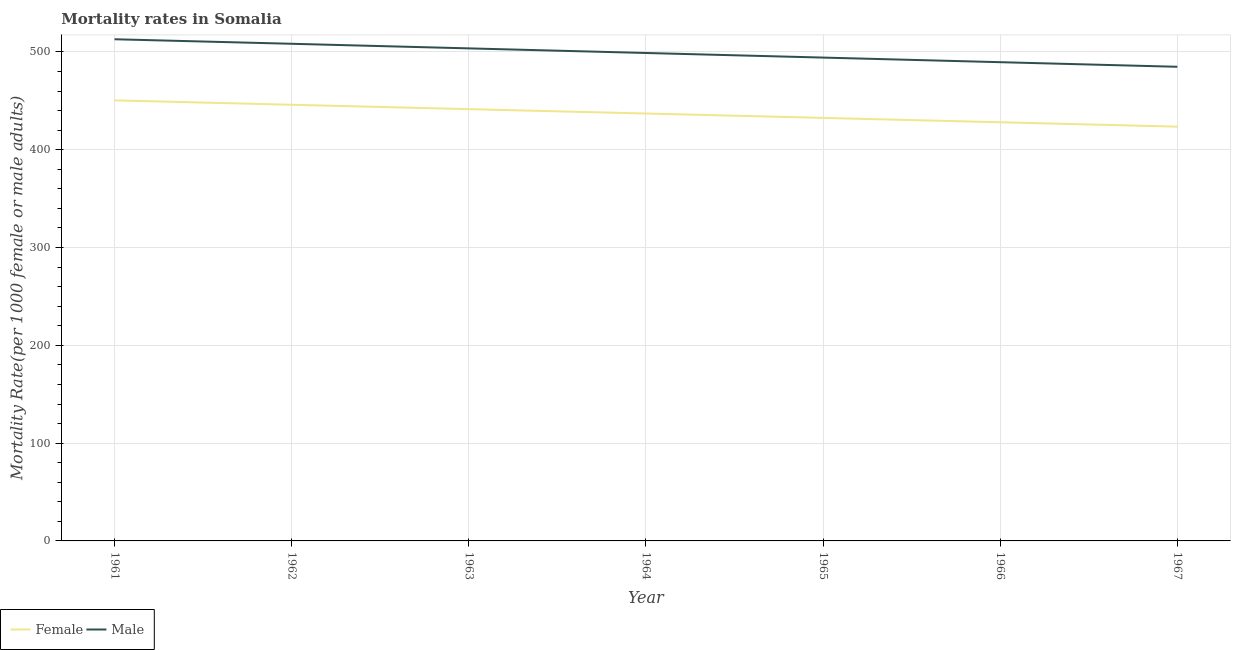Does the line corresponding to female mortality rate intersect with the line corresponding to male mortality rate?
Keep it short and to the point. No. Is the number of lines equal to the number of legend labels?
Your answer should be compact. Yes. What is the female mortality rate in 1961?
Keep it short and to the point. 450.5. Across all years, what is the maximum female mortality rate?
Provide a succinct answer. 450.5. Across all years, what is the minimum female mortality rate?
Give a very brief answer. 423.62. In which year was the male mortality rate maximum?
Your answer should be compact. 1961. In which year was the male mortality rate minimum?
Offer a very short reply. 1967. What is the total female mortality rate in the graph?
Offer a very short reply. 3059.34. What is the difference between the female mortality rate in 1961 and that in 1963?
Ensure brevity in your answer.  8.98. What is the difference between the female mortality rate in 1967 and the male mortality rate in 1962?
Offer a very short reply. -84.73. What is the average male mortality rate per year?
Provide a succinct answer. 498.93. In the year 1963, what is the difference between the female mortality rate and male mortality rate?
Offer a terse response. -62.13. In how many years, is the male mortality rate greater than 160?
Offer a very short reply. 7. What is the ratio of the female mortality rate in 1961 to that in 1965?
Offer a very short reply. 1.04. Is the difference between the female mortality rate in 1964 and 1966 greater than the difference between the male mortality rate in 1964 and 1966?
Make the answer very short. No. What is the difference between the highest and the second highest male mortality rate?
Provide a succinct answer. 4.64. What is the difference between the highest and the lowest female mortality rate?
Your answer should be very brief. 26.88. Does the female mortality rate monotonically increase over the years?
Offer a very short reply. No. Is the male mortality rate strictly greater than the female mortality rate over the years?
Offer a terse response. Yes. Is the female mortality rate strictly less than the male mortality rate over the years?
Ensure brevity in your answer.  Yes. What is the difference between two consecutive major ticks on the Y-axis?
Your response must be concise. 100. Where does the legend appear in the graph?
Your answer should be very brief. Bottom left. How many legend labels are there?
Ensure brevity in your answer.  2. What is the title of the graph?
Make the answer very short. Mortality rates in Somalia. What is the label or title of the X-axis?
Your answer should be very brief. Year. What is the label or title of the Y-axis?
Your answer should be compact. Mortality Rate(per 1000 female or male adults). What is the Mortality Rate(per 1000 female or male adults) in Female in 1961?
Your response must be concise. 450.5. What is the Mortality Rate(per 1000 female or male adults) in Male in 1961?
Provide a short and direct response. 512.99. What is the Mortality Rate(per 1000 female or male adults) of Female in 1962?
Make the answer very short. 446. What is the Mortality Rate(per 1000 female or male adults) in Male in 1962?
Offer a very short reply. 508.35. What is the Mortality Rate(per 1000 female or male adults) of Female in 1963?
Ensure brevity in your answer.  441.52. What is the Mortality Rate(per 1000 female or male adults) in Male in 1963?
Offer a terse response. 503.65. What is the Mortality Rate(per 1000 female or male adults) of Female in 1964?
Your answer should be very brief. 437.04. What is the Mortality Rate(per 1000 female or male adults) in Male in 1964?
Your answer should be very brief. 498.94. What is the Mortality Rate(per 1000 female or male adults) of Female in 1965?
Keep it short and to the point. 432.57. What is the Mortality Rate(per 1000 female or male adults) of Male in 1965?
Your answer should be very brief. 494.24. What is the Mortality Rate(per 1000 female or male adults) of Female in 1966?
Provide a short and direct response. 428.09. What is the Mortality Rate(per 1000 female or male adults) of Male in 1966?
Your answer should be very brief. 489.53. What is the Mortality Rate(per 1000 female or male adults) in Female in 1967?
Offer a very short reply. 423.62. What is the Mortality Rate(per 1000 female or male adults) of Male in 1967?
Make the answer very short. 484.82. Across all years, what is the maximum Mortality Rate(per 1000 female or male adults) of Female?
Your response must be concise. 450.5. Across all years, what is the maximum Mortality Rate(per 1000 female or male adults) in Male?
Give a very brief answer. 512.99. Across all years, what is the minimum Mortality Rate(per 1000 female or male adults) of Female?
Provide a short and direct response. 423.62. Across all years, what is the minimum Mortality Rate(per 1000 female or male adults) of Male?
Offer a terse response. 484.82. What is the total Mortality Rate(per 1000 female or male adults) of Female in the graph?
Offer a very short reply. 3059.34. What is the total Mortality Rate(per 1000 female or male adults) of Male in the graph?
Give a very brief answer. 3492.51. What is the difference between the Mortality Rate(per 1000 female or male adults) of Female in 1961 and that in 1962?
Your response must be concise. 4.5. What is the difference between the Mortality Rate(per 1000 female or male adults) in Male in 1961 and that in 1962?
Ensure brevity in your answer.  4.64. What is the difference between the Mortality Rate(per 1000 female or male adults) in Female in 1961 and that in 1963?
Offer a very short reply. 8.98. What is the difference between the Mortality Rate(per 1000 female or male adults) in Male in 1961 and that in 1963?
Give a very brief answer. 9.34. What is the difference between the Mortality Rate(per 1000 female or male adults) in Female in 1961 and that in 1964?
Make the answer very short. 13.45. What is the difference between the Mortality Rate(per 1000 female or male adults) in Male in 1961 and that in 1964?
Your answer should be compact. 14.05. What is the difference between the Mortality Rate(per 1000 female or male adults) in Female in 1961 and that in 1965?
Offer a very short reply. 17.93. What is the difference between the Mortality Rate(per 1000 female or male adults) in Male in 1961 and that in 1965?
Make the answer very short. 18.75. What is the difference between the Mortality Rate(per 1000 female or male adults) in Female in 1961 and that in 1966?
Provide a short and direct response. 22.4. What is the difference between the Mortality Rate(per 1000 female or male adults) in Male in 1961 and that in 1966?
Give a very brief answer. 23.46. What is the difference between the Mortality Rate(per 1000 female or male adults) of Female in 1961 and that in 1967?
Make the answer very short. 26.88. What is the difference between the Mortality Rate(per 1000 female or male adults) of Male in 1961 and that in 1967?
Provide a short and direct response. 28.16. What is the difference between the Mortality Rate(per 1000 female or male adults) in Female in 1962 and that in 1963?
Offer a very short reply. 4.48. What is the difference between the Mortality Rate(per 1000 female or male adults) of Male in 1962 and that in 1963?
Ensure brevity in your answer.  4.71. What is the difference between the Mortality Rate(per 1000 female or male adults) of Female in 1962 and that in 1964?
Give a very brief answer. 8.95. What is the difference between the Mortality Rate(per 1000 female or male adults) in Male in 1962 and that in 1964?
Keep it short and to the point. 9.41. What is the difference between the Mortality Rate(per 1000 female or male adults) in Female in 1962 and that in 1965?
Offer a terse response. 13.43. What is the difference between the Mortality Rate(per 1000 female or male adults) of Male in 1962 and that in 1965?
Provide a succinct answer. 14.12. What is the difference between the Mortality Rate(per 1000 female or male adults) in Female in 1962 and that in 1966?
Offer a terse response. 17.9. What is the difference between the Mortality Rate(per 1000 female or male adults) of Male in 1962 and that in 1966?
Give a very brief answer. 18.82. What is the difference between the Mortality Rate(per 1000 female or male adults) in Female in 1962 and that in 1967?
Your answer should be compact. 22.38. What is the difference between the Mortality Rate(per 1000 female or male adults) in Male in 1962 and that in 1967?
Ensure brevity in your answer.  23.53. What is the difference between the Mortality Rate(per 1000 female or male adults) of Female in 1963 and that in 1964?
Ensure brevity in your answer.  4.47. What is the difference between the Mortality Rate(per 1000 female or male adults) in Male in 1963 and that in 1964?
Provide a short and direct response. 4.71. What is the difference between the Mortality Rate(per 1000 female or male adults) of Female in 1963 and that in 1965?
Make the answer very short. 8.95. What is the difference between the Mortality Rate(per 1000 female or male adults) in Male in 1963 and that in 1965?
Offer a terse response. 9.41. What is the difference between the Mortality Rate(per 1000 female or male adults) in Female in 1963 and that in 1966?
Offer a very short reply. 13.43. What is the difference between the Mortality Rate(per 1000 female or male adults) in Male in 1963 and that in 1966?
Offer a terse response. 14.12. What is the difference between the Mortality Rate(per 1000 female or male adults) of Female in 1963 and that in 1967?
Provide a short and direct response. 17.9. What is the difference between the Mortality Rate(per 1000 female or male adults) in Male in 1963 and that in 1967?
Offer a very short reply. 18.82. What is the difference between the Mortality Rate(per 1000 female or male adults) of Female in 1964 and that in 1965?
Offer a very short reply. 4.47. What is the difference between the Mortality Rate(per 1000 female or male adults) in Male in 1964 and that in 1965?
Provide a short and direct response. 4.71. What is the difference between the Mortality Rate(per 1000 female or male adults) of Female in 1964 and that in 1966?
Your answer should be very brief. 8.95. What is the difference between the Mortality Rate(per 1000 female or male adults) in Male in 1964 and that in 1966?
Your answer should be very brief. 9.41. What is the difference between the Mortality Rate(per 1000 female or male adults) in Female in 1964 and that in 1967?
Ensure brevity in your answer.  13.43. What is the difference between the Mortality Rate(per 1000 female or male adults) in Male in 1964 and that in 1967?
Your response must be concise. 14.12. What is the difference between the Mortality Rate(per 1000 female or male adults) in Female in 1965 and that in 1966?
Your answer should be very brief. 4.47. What is the difference between the Mortality Rate(per 1000 female or male adults) in Male in 1965 and that in 1966?
Provide a succinct answer. 4.71. What is the difference between the Mortality Rate(per 1000 female or male adults) in Female in 1965 and that in 1967?
Give a very brief answer. 8.95. What is the difference between the Mortality Rate(per 1000 female or male adults) of Male in 1965 and that in 1967?
Offer a terse response. 9.41. What is the difference between the Mortality Rate(per 1000 female or male adults) of Female in 1966 and that in 1967?
Your response must be concise. 4.48. What is the difference between the Mortality Rate(per 1000 female or male adults) in Male in 1966 and that in 1967?
Offer a very short reply. 4.71. What is the difference between the Mortality Rate(per 1000 female or male adults) in Female in 1961 and the Mortality Rate(per 1000 female or male adults) in Male in 1962?
Keep it short and to the point. -57.85. What is the difference between the Mortality Rate(per 1000 female or male adults) in Female in 1961 and the Mortality Rate(per 1000 female or male adults) in Male in 1963?
Keep it short and to the point. -53.15. What is the difference between the Mortality Rate(per 1000 female or male adults) of Female in 1961 and the Mortality Rate(per 1000 female or male adults) of Male in 1964?
Give a very brief answer. -48.44. What is the difference between the Mortality Rate(per 1000 female or male adults) in Female in 1961 and the Mortality Rate(per 1000 female or male adults) in Male in 1965?
Your response must be concise. -43.74. What is the difference between the Mortality Rate(per 1000 female or male adults) in Female in 1961 and the Mortality Rate(per 1000 female or male adults) in Male in 1966?
Ensure brevity in your answer.  -39.03. What is the difference between the Mortality Rate(per 1000 female or male adults) of Female in 1961 and the Mortality Rate(per 1000 female or male adults) of Male in 1967?
Ensure brevity in your answer.  -34.33. What is the difference between the Mortality Rate(per 1000 female or male adults) in Female in 1962 and the Mortality Rate(per 1000 female or male adults) in Male in 1963?
Provide a short and direct response. -57.65. What is the difference between the Mortality Rate(per 1000 female or male adults) in Female in 1962 and the Mortality Rate(per 1000 female or male adults) in Male in 1964?
Your answer should be very brief. -52.95. What is the difference between the Mortality Rate(per 1000 female or male adults) in Female in 1962 and the Mortality Rate(per 1000 female or male adults) in Male in 1965?
Your response must be concise. -48.24. What is the difference between the Mortality Rate(per 1000 female or male adults) in Female in 1962 and the Mortality Rate(per 1000 female or male adults) in Male in 1966?
Offer a very short reply. -43.53. What is the difference between the Mortality Rate(per 1000 female or male adults) of Female in 1962 and the Mortality Rate(per 1000 female or male adults) of Male in 1967?
Offer a terse response. -38.83. What is the difference between the Mortality Rate(per 1000 female or male adults) of Female in 1963 and the Mortality Rate(per 1000 female or male adults) of Male in 1964?
Provide a short and direct response. -57.42. What is the difference between the Mortality Rate(per 1000 female or male adults) of Female in 1963 and the Mortality Rate(per 1000 female or male adults) of Male in 1965?
Make the answer very short. -52.72. What is the difference between the Mortality Rate(per 1000 female or male adults) in Female in 1963 and the Mortality Rate(per 1000 female or male adults) in Male in 1966?
Your response must be concise. -48.01. What is the difference between the Mortality Rate(per 1000 female or male adults) of Female in 1963 and the Mortality Rate(per 1000 female or male adults) of Male in 1967?
Offer a very short reply. -43.3. What is the difference between the Mortality Rate(per 1000 female or male adults) of Female in 1964 and the Mortality Rate(per 1000 female or male adults) of Male in 1965?
Give a very brief answer. -57.19. What is the difference between the Mortality Rate(per 1000 female or male adults) of Female in 1964 and the Mortality Rate(per 1000 female or male adults) of Male in 1966?
Keep it short and to the point. -52.48. What is the difference between the Mortality Rate(per 1000 female or male adults) in Female in 1964 and the Mortality Rate(per 1000 female or male adults) in Male in 1967?
Your answer should be compact. -47.78. What is the difference between the Mortality Rate(per 1000 female or male adults) in Female in 1965 and the Mortality Rate(per 1000 female or male adults) in Male in 1966?
Provide a succinct answer. -56.96. What is the difference between the Mortality Rate(per 1000 female or male adults) of Female in 1965 and the Mortality Rate(per 1000 female or male adults) of Male in 1967?
Ensure brevity in your answer.  -52.26. What is the difference between the Mortality Rate(per 1000 female or male adults) in Female in 1966 and the Mortality Rate(per 1000 female or male adults) in Male in 1967?
Provide a succinct answer. -56.73. What is the average Mortality Rate(per 1000 female or male adults) of Female per year?
Your answer should be compact. 437.05. What is the average Mortality Rate(per 1000 female or male adults) in Male per year?
Give a very brief answer. 498.93. In the year 1961, what is the difference between the Mortality Rate(per 1000 female or male adults) of Female and Mortality Rate(per 1000 female or male adults) of Male?
Keep it short and to the point. -62.49. In the year 1962, what is the difference between the Mortality Rate(per 1000 female or male adults) of Female and Mortality Rate(per 1000 female or male adults) of Male?
Keep it short and to the point. -62.36. In the year 1963, what is the difference between the Mortality Rate(per 1000 female or male adults) in Female and Mortality Rate(per 1000 female or male adults) in Male?
Offer a terse response. -62.13. In the year 1964, what is the difference between the Mortality Rate(per 1000 female or male adults) of Female and Mortality Rate(per 1000 female or male adults) of Male?
Make the answer very short. -61.9. In the year 1965, what is the difference between the Mortality Rate(per 1000 female or male adults) in Female and Mortality Rate(per 1000 female or male adults) in Male?
Ensure brevity in your answer.  -61.67. In the year 1966, what is the difference between the Mortality Rate(per 1000 female or male adults) of Female and Mortality Rate(per 1000 female or male adults) of Male?
Make the answer very short. -61.44. In the year 1967, what is the difference between the Mortality Rate(per 1000 female or male adults) in Female and Mortality Rate(per 1000 female or male adults) in Male?
Provide a succinct answer. -61.21. What is the ratio of the Mortality Rate(per 1000 female or male adults) of Female in 1961 to that in 1962?
Your answer should be compact. 1.01. What is the ratio of the Mortality Rate(per 1000 female or male adults) in Male in 1961 to that in 1962?
Your answer should be very brief. 1.01. What is the ratio of the Mortality Rate(per 1000 female or male adults) of Female in 1961 to that in 1963?
Make the answer very short. 1.02. What is the ratio of the Mortality Rate(per 1000 female or male adults) in Male in 1961 to that in 1963?
Give a very brief answer. 1.02. What is the ratio of the Mortality Rate(per 1000 female or male adults) in Female in 1961 to that in 1964?
Your answer should be compact. 1.03. What is the ratio of the Mortality Rate(per 1000 female or male adults) of Male in 1961 to that in 1964?
Provide a succinct answer. 1.03. What is the ratio of the Mortality Rate(per 1000 female or male adults) of Female in 1961 to that in 1965?
Your answer should be compact. 1.04. What is the ratio of the Mortality Rate(per 1000 female or male adults) of Male in 1961 to that in 1965?
Give a very brief answer. 1.04. What is the ratio of the Mortality Rate(per 1000 female or male adults) of Female in 1961 to that in 1966?
Give a very brief answer. 1.05. What is the ratio of the Mortality Rate(per 1000 female or male adults) in Male in 1961 to that in 1966?
Offer a terse response. 1.05. What is the ratio of the Mortality Rate(per 1000 female or male adults) in Female in 1961 to that in 1967?
Give a very brief answer. 1.06. What is the ratio of the Mortality Rate(per 1000 female or male adults) of Male in 1961 to that in 1967?
Your answer should be compact. 1.06. What is the ratio of the Mortality Rate(per 1000 female or male adults) of Male in 1962 to that in 1963?
Keep it short and to the point. 1.01. What is the ratio of the Mortality Rate(per 1000 female or male adults) in Female in 1962 to that in 1964?
Your answer should be very brief. 1.02. What is the ratio of the Mortality Rate(per 1000 female or male adults) in Male in 1962 to that in 1964?
Provide a short and direct response. 1.02. What is the ratio of the Mortality Rate(per 1000 female or male adults) of Female in 1962 to that in 1965?
Ensure brevity in your answer.  1.03. What is the ratio of the Mortality Rate(per 1000 female or male adults) of Male in 1962 to that in 1965?
Your response must be concise. 1.03. What is the ratio of the Mortality Rate(per 1000 female or male adults) of Female in 1962 to that in 1966?
Make the answer very short. 1.04. What is the ratio of the Mortality Rate(per 1000 female or male adults) of Male in 1962 to that in 1966?
Your answer should be very brief. 1.04. What is the ratio of the Mortality Rate(per 1000 female or male adults) in Female in 1962 to that in 1967?
Offer a very short reply. 1.05. What is the ratio of the Mortality Rate(per 1000 female or male adults) in Male in 1962 to that in 1967?
Ensure brevity in your answer.  1.05. What is the ratio of the Mortality Rate(per 1000 female or male adults) in Female in 1963 to that in 1964?
Offer a very short reply. 1.01. What is the ratio of the Mortality Rate(per 1000 female or male adults) in Male in 1963 to that in 1964?
Keep it short and to the point. 1.01. What is the ratio of the Mortality Rate(per 1000 female or male adults) of Female in 1963 to that in 1965?
Make the answer very short. 1.02. What is the ratio of the Mortality Rate(per 1000 female or male adults) in Female in 1963 to that in 1966?
Make the answer very short. 1.03. What is the ratio of the Mortality Rate(per 1000 female or male adults) of Male in 1963 to that in 1966?
Provide a succinct answer. 1.03. What is the ratio of the Mortality Rate(per 1000 female or male adults) in Female in 1963 to that in 1967?
Provide a short and direct response. 1.04. What is the ratio of the Mortality Rate(per 1000 female or male adults) of Male in 1963 to that in 1967?
Ensure brevity in your answer.  1.04. What is the ratio of the Mortality Rate(per 1000 female or male adults) of Female in 1964 to that in 1965?
Provide a short and direct response. 1.01. What is the ratio of the Mortality Rate(per 1000 female or male adults) in Male in 1964 to that in 1965?
Provide a succinct answer. 1.01. What is the ratio of the Mortality Rate(per 1000 female or male adults) of Female in 1964 to that in 1966?
Your response must be concise. 1.02. What is the ratio of the Mortality Rate(per 1000 female or male adults) of Male in 1964 to that in 1966?
Provide a short and direct response. 1.02. What is the ratio of the Mortality Rate(per 1000 female or male adults) of Female in 1964 to that in 1967?
Make the answer very short. 1.03. What is the ratio of the Mortality Rate(per 1000 female or male adults) in Male in 1964 to that in 1967?
Keep it short and to the point. 1.03. What is the ratio of the Mortality Rate(per 1000 female or male adults) in Female in 1965 to that in 1966?
Provide a succinct answer. 1.01. What is the ratio of the Mortality Rate(per 1000 female or male adults) in Male in 1965 to that in 1966?
Offer a terse response. 1.01. What is the ratio of the Mortality Rate(per 1000 female or male adults) of Female in 1965 to that in 1967?
Provide a short and direct response. 1.02. What is the ratio of the Mortality Rate(per 1000 female or male adults) of Male in 1965 to that in 1967?
Give a very brief answer. 1.02. What is the ratio of the Mortality Rate(per 1000 female or male adults) in Female in 1966 to that in 1967?
Make the answer very short. 1.01. What is the ratio of the Mortality Rate(per 1000 female or male adults) in Male in 1966 to that in 1967?
Make the answer very short. 1.01. What is the difference between the highest and the second highest Mortality Rate(per 1000 female or male adults) of Female?
Your response must be concise. 4.5. What is the difference between the highest and the second highest Mortality Rate(per 1000 female or male adults) in Male?
Your answer should be very brief. 4.64. What is the difference between the highest and the lowest Mortality Rate(per 1000 female or male adults) in Female?
Ensure brevity in your answer.  26.88. What is the difference between the highest and the lowest Mortality Rate(per 1000 female or male adults) of Male?
Keep it short and to the point. 28.16. 